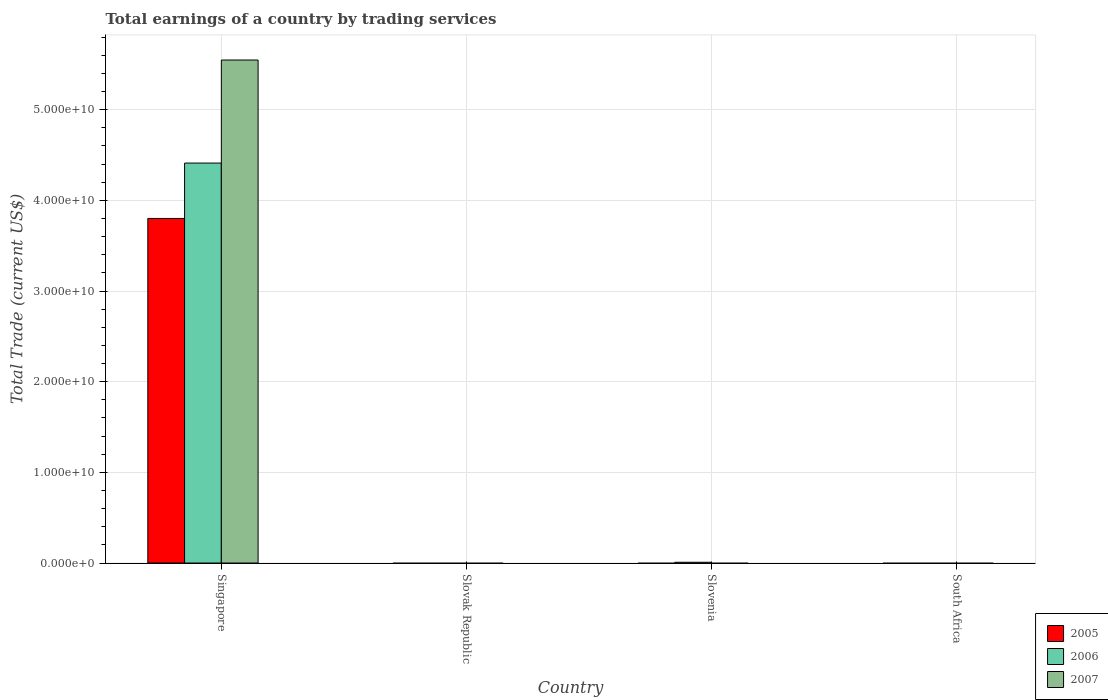Are the number of bars per tick equal to the number of legend labels?
Offer a very short reply. No. Are the number of bars on each tick of the X-axis equal?
Make the answer very short. No. What is the label of the 2nd group of bars from the left?
Keep it short and to the point. Slovak Republic. In how many cases, is the number of bars for a given country not equal to the number of legend labels?
Provide a succinct answer. 3. What is the total earnings in 2007 in South Africa?
Your answer should be very brief. 0. Across all countries, what is the maximum total earnings in 2006?
Provide a succinct answer. 4.41e+1. In which country was the total earnings in 2005 maximum?
Provide a short and direct response. Singapore. What is the total total earnings in 2007 in the graph?
Ensure brevity in your answer.  5.55e+1. What is the difference between the total earnings in 2006 in Singapore and that in Slovenia?
Your answer should be compact. 4.40e+1. What is the difference between the total earnings in 2005 in Singapore and the total earnings in 2006 in South Africa?
Keep it short and to the point. 3.80e+1. What is the average total earnings in 2007 per country?
Offer a terse response. 1.39e+1. What is the difference between the total earnings of/in 2006 and total earnings of/in 2005 in Singapore?
Keep it short and to the point. 6.11e+09. What is the difference between the highest and the lowest total earnings in 2006?
Make the answer very short. 4.41e+1. How many bars are there?
Provide a short and direct response. 4. Are all the bars in the graph horizontal?
Your answer should be compact. No. How many countries are there in the graph?
Provide a short and direct response. 4. Does the graph contain any zero values?
Offer a terse response. Yes. Does the graph contain grids?
Provide a short and direct response. Yes. How are the legend labels stacked?
Provide a short and direct response. Vertical. What is the title of the graph?
Give a very brief answer. Total earnings of a country by trading services. What is the label or title of the Y-axis?
Your response must be concise. Total Trade (current US$). What is the Total Trade (current US$) of 2005 in Singapore?
Your answer should be compact. 3.80e+1. What is the Total Trade (current US$) in 2006 in Singapore?
Offer a terse response. 4.41e+1. What is the Total Trade (current US$) in 2007 in Singapore?
Your response must be concise. 5.55e+1. What is the Total Trade (current US$) in 2005 in Slovak Republic?
Your response must be concise. 0. What is the Total Trade (current US$) of 2006 in Slovak Republic?
Give a very brief answer. 0. What is the Total Trade (current US$) of 2006 in Slovenia?
Offer a terse response. 8.38e+07. What is the Total Trade (current US$) of 2006 in South Africa?
Offer a very short reply. 0. What is the Total Trade (current US$) of 2007 in South Africa?
Ensure brevity in your answer.  0. Across all countries, what is the maximum Total Trade (current US$) in 2005?
Make the answer very short. 3.80e+1. Across all countries, what is the maximum Total Trade (current US$) of 2006?
Provide a succinct answer. 4.41e+1. Across all countries, what is the maximum Total Trade (current US$) of 2007?
Your answer should be very brief. 5.55e+1. Across all countries, what is the minimum Total Trade (current US$) of 2006?
Provide a succinct answer. 0. Across all countries, what is the minimum Total Trade (current US$) in 2007?
Provide a succinct answer. 0. What is the total Total Trade (current US$) in 2005 in the graph?
Ensure brevity in your answer.  3.80e+1. What is the total Total Trade (current US$) of 2006 in the graph?
Ensure brevity in your answer.  4.42e+1. What is the total Total Trade (current US$) in 2007 in the graph?
Your answer should be compact. 5.55e+1. What is the difference between the Total Trade (current US$) in 2006 in Singapore and that in Slovenia?
Your answer should be compact. 4.40e+1. What is the difference between the Total Trade (current US$) in 2005 in Singapore and the Total Trade (current US$) in 2006 in Slovenia?
Offer a terse response. 3.79e+1. What is the average Total Trade (current US$) in 2005 per country?
Offer a very short reply. 9.50e+09. What is the average Total Trade (current US$) of 2006 per country?
Keep it short and to the point. 1.10e+1. What is the average Total Trade (current US$) of 2007 per country?
Your answer should be very brief. 1.39e+1. What is the difference between the Total Trade (current US$) of 2005 and Total Trade (current US$) of 2006 in Singapore?
Give a very brief answer. -6.11e+09. What is the difference between the Total Trade (current US$) of 2005 and Total Trade (current US$) of 2007 in Singapore?
Your answer should be compact. -1.75e+1. What is the difference between the Total Trade (current US$) of 2006 and Total Trade (current US$) of 2007 in Singapore?
Make the answer very short. -1.14e+1. What is the ratio of the Total Trade (current US$) in 2006 in Singapore to that in Slovenia?
Give a very brief answer. 526.53. What is the difference between the highest and the lowest Total Trade (current US$) in 2005?
Ensure brevity in your answer.  3.80e+1. What is the difference between the highest and the lowest Total Trade (current US$) in 2006?
Make the answer very short. 4.41e+1. What is the difference between the highest and the lowest Total Trade (current US$) in 2007?
Your response must be concise. 5.55e+1. 